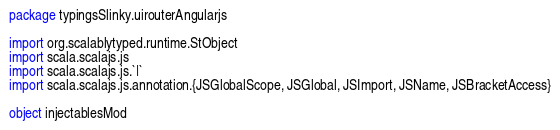<code> <loc_0><loc_0><loc_500><loc_500><_Scala_>package typingsSlinky.uirouterAngularjs

import org.scalablytyped.runtime.StObject
import scala.scalajs.js
import scala.scalajs.js.`|`
import scala.scalajs.js.annotation.{JSGlobalScope, JSGlobal, JSImport, JSName, JSBracketAccess}

object injectablesMod
</code> 